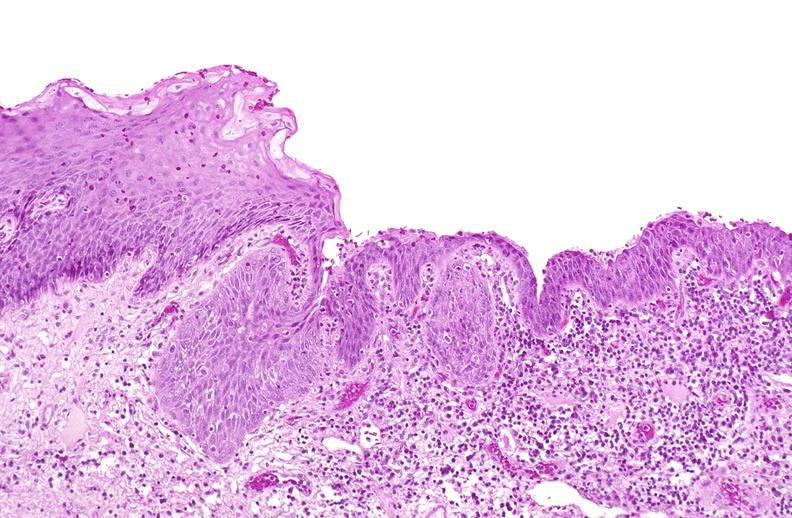what is present?
Answer the question using a single word or phrase. Urinary 